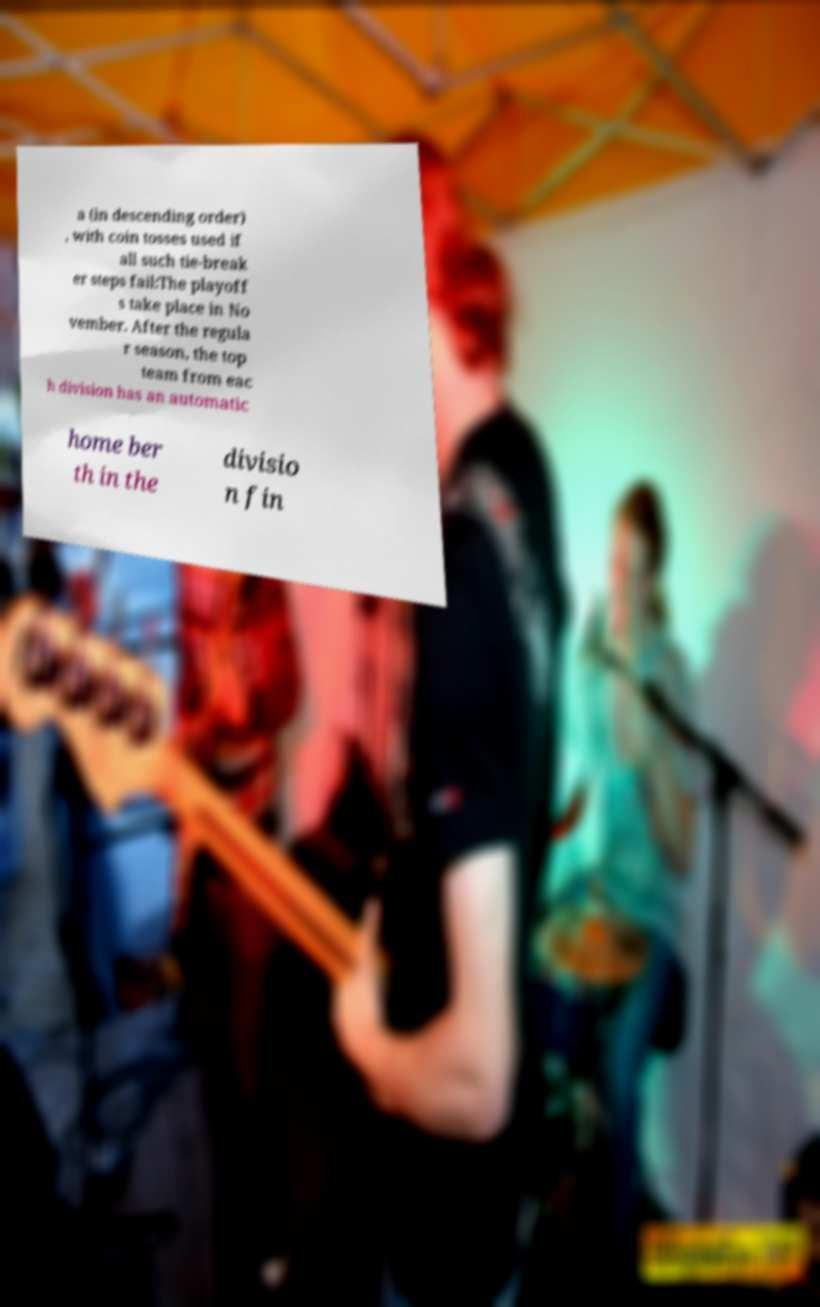For documentation purposes, I need the text within this image transcribed. Could you provide that? a (in descending order) , with coin tosses used if all such tie-break er steps fail:The playoff s take place in No vember. After the regula r season, the top team from eac h division has an automatic home ber th in the divisio n fin 